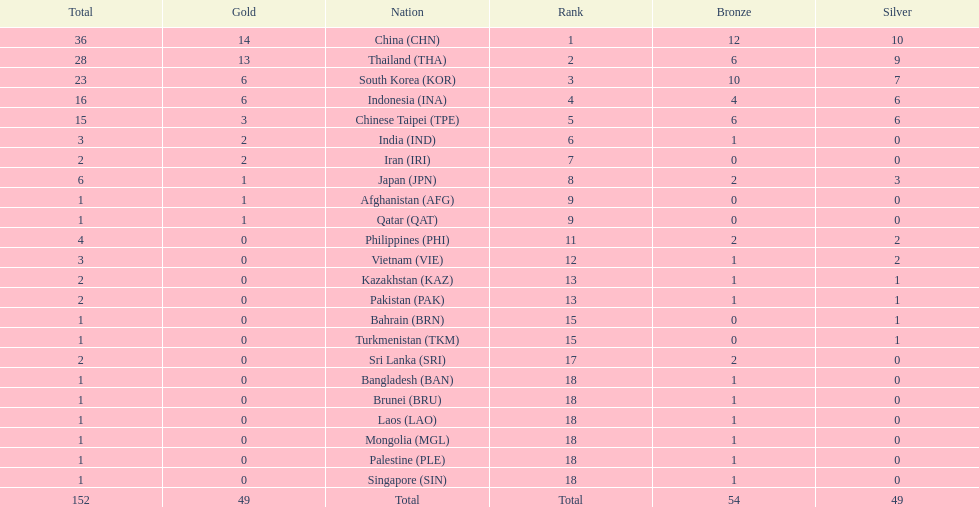What is the total number of nations that participated in the beach games of 2012? 23. 